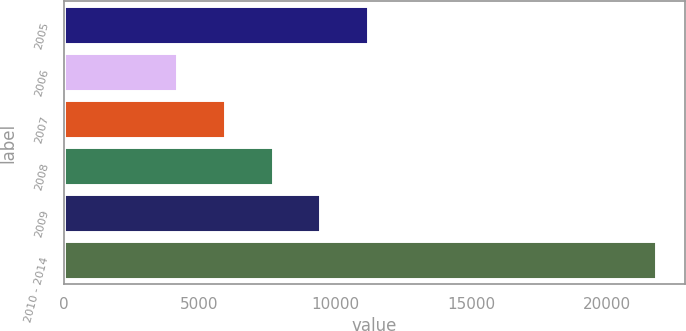Convert chart. <chart><loc_0><loc_0><loc_500><loc_500><bar_chart><fcel>2005<fcel>2006<fcel>2007<fcel>2008<fcel>2009<fcel>2010 - 2014<nl><fcel>11206.8<fcel>4162<fcel>5923.2<fcel>7684.4<fcel>9445.6<fcel>21774<nl></chart> 